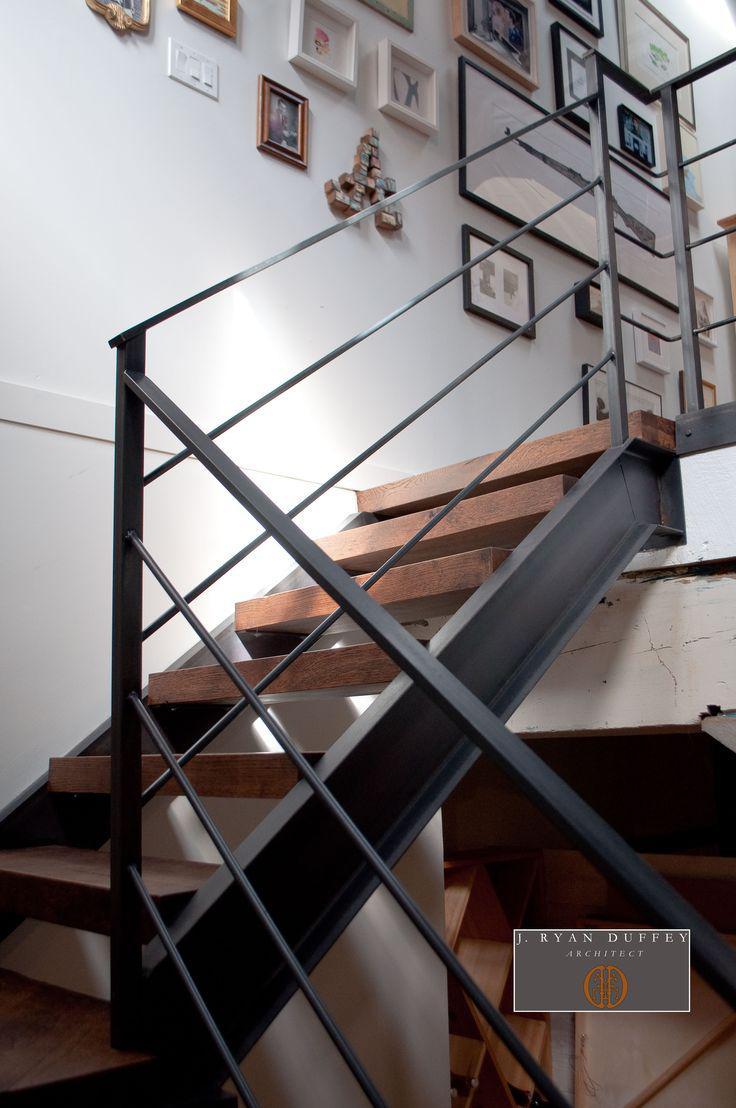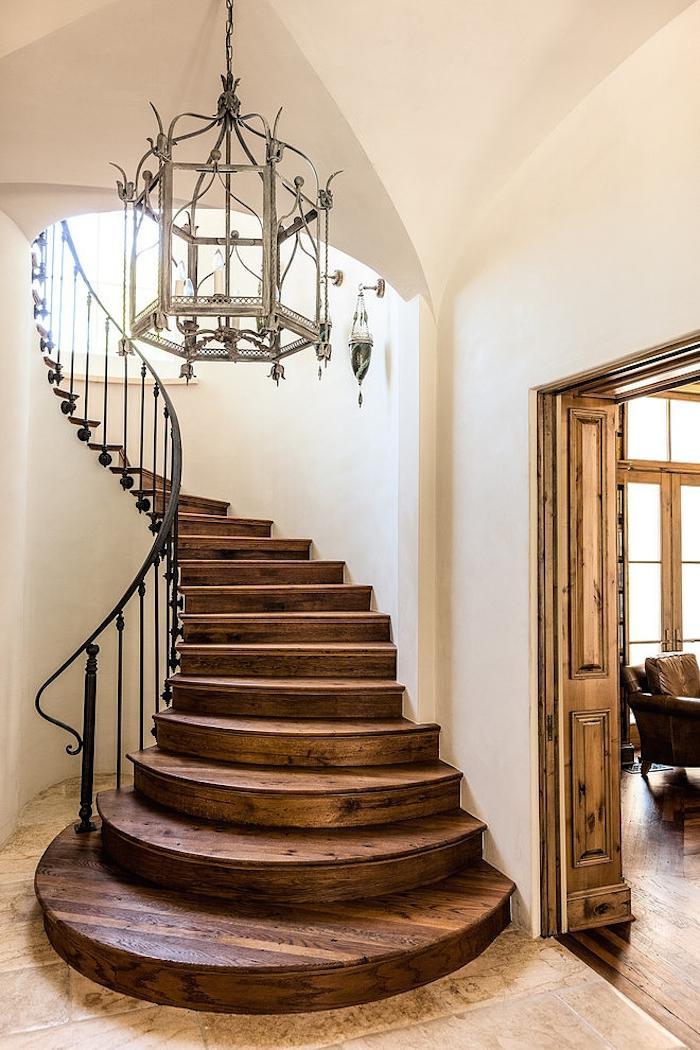The first image is the image on the left, the second image is the image on the right. Analyze the images presented: Is the assertion "There is one set of stairs that has no risers." valid? Answer yes or no. Yes. 